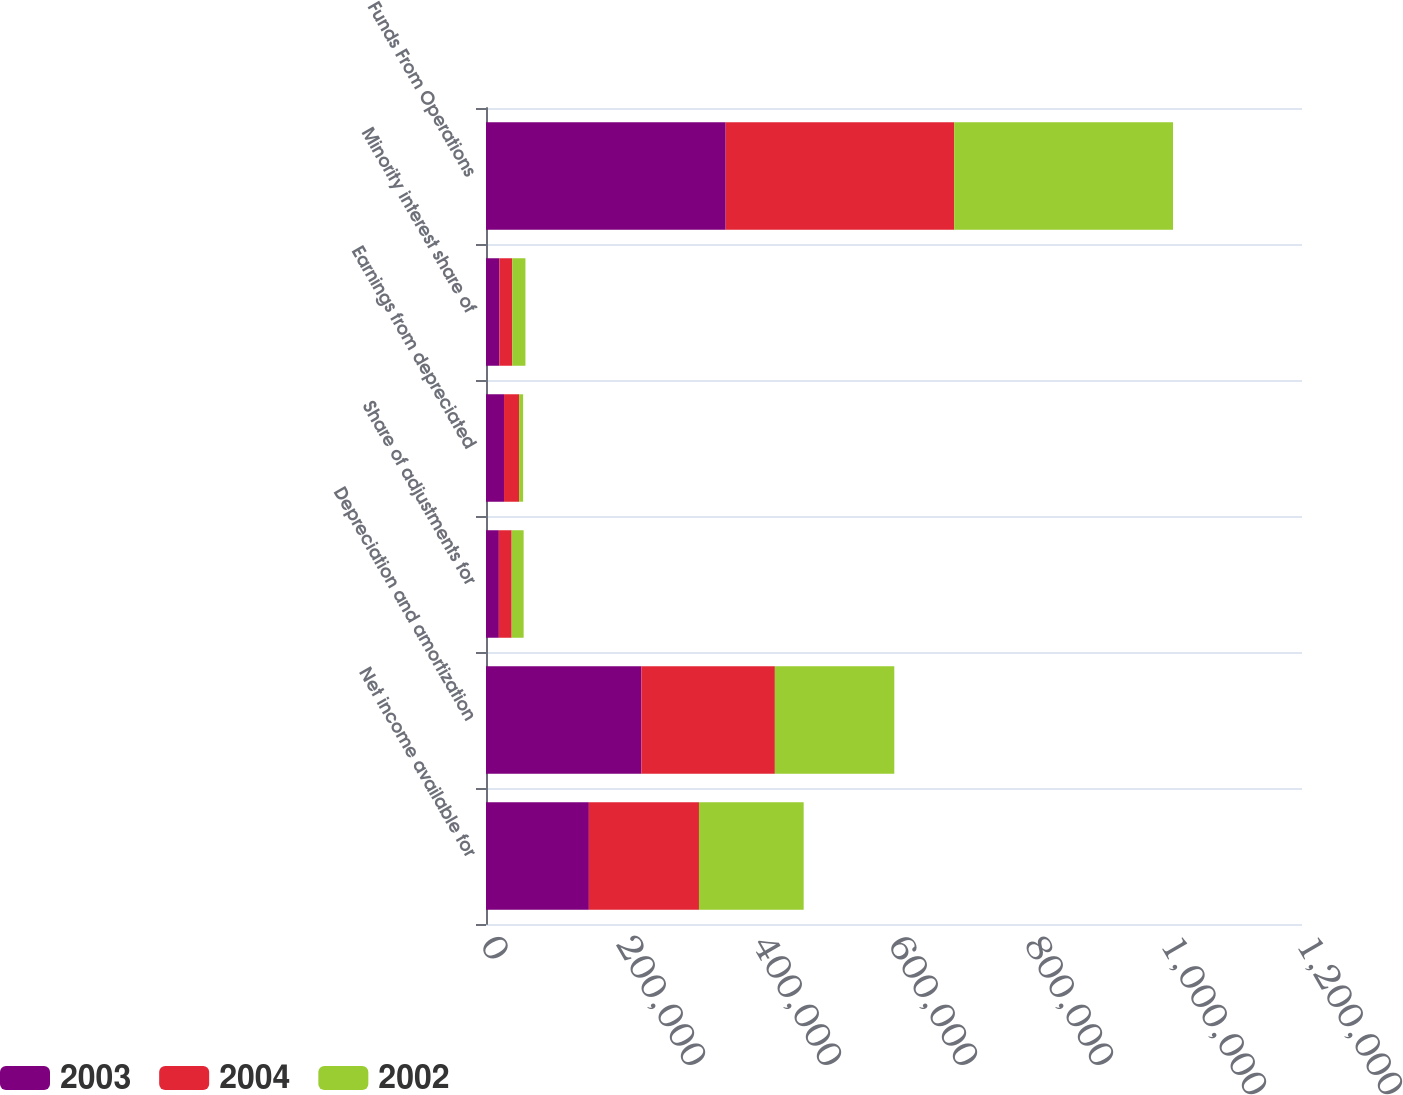Convert chart. <chart><loc_0><loc_0><loc_500><loc_500><stacked_bar_chart><ecel><fcel>Net income available for<fcel>Depreciation and amortization<fcel>Share of adjustments for<fcel>Earnings from depreciated<fcel>Minority interest share of<fcel>Funds From Operations<nl><fcel>2003<fcel>151279<fcel>228582<fcel>18901<fcel>26510<fcel>19783<fcel>352469<nl><fcel>2004<fcel>161911<fcel>196234<fcel>18839<fcel>22141<fcel>18854<fcel>335989<nl><fcel>2002<fcel>153969<fcel>175621<fcel>17598<fcel>5949<fcel>19353<fcel>321886<nl></chart> 